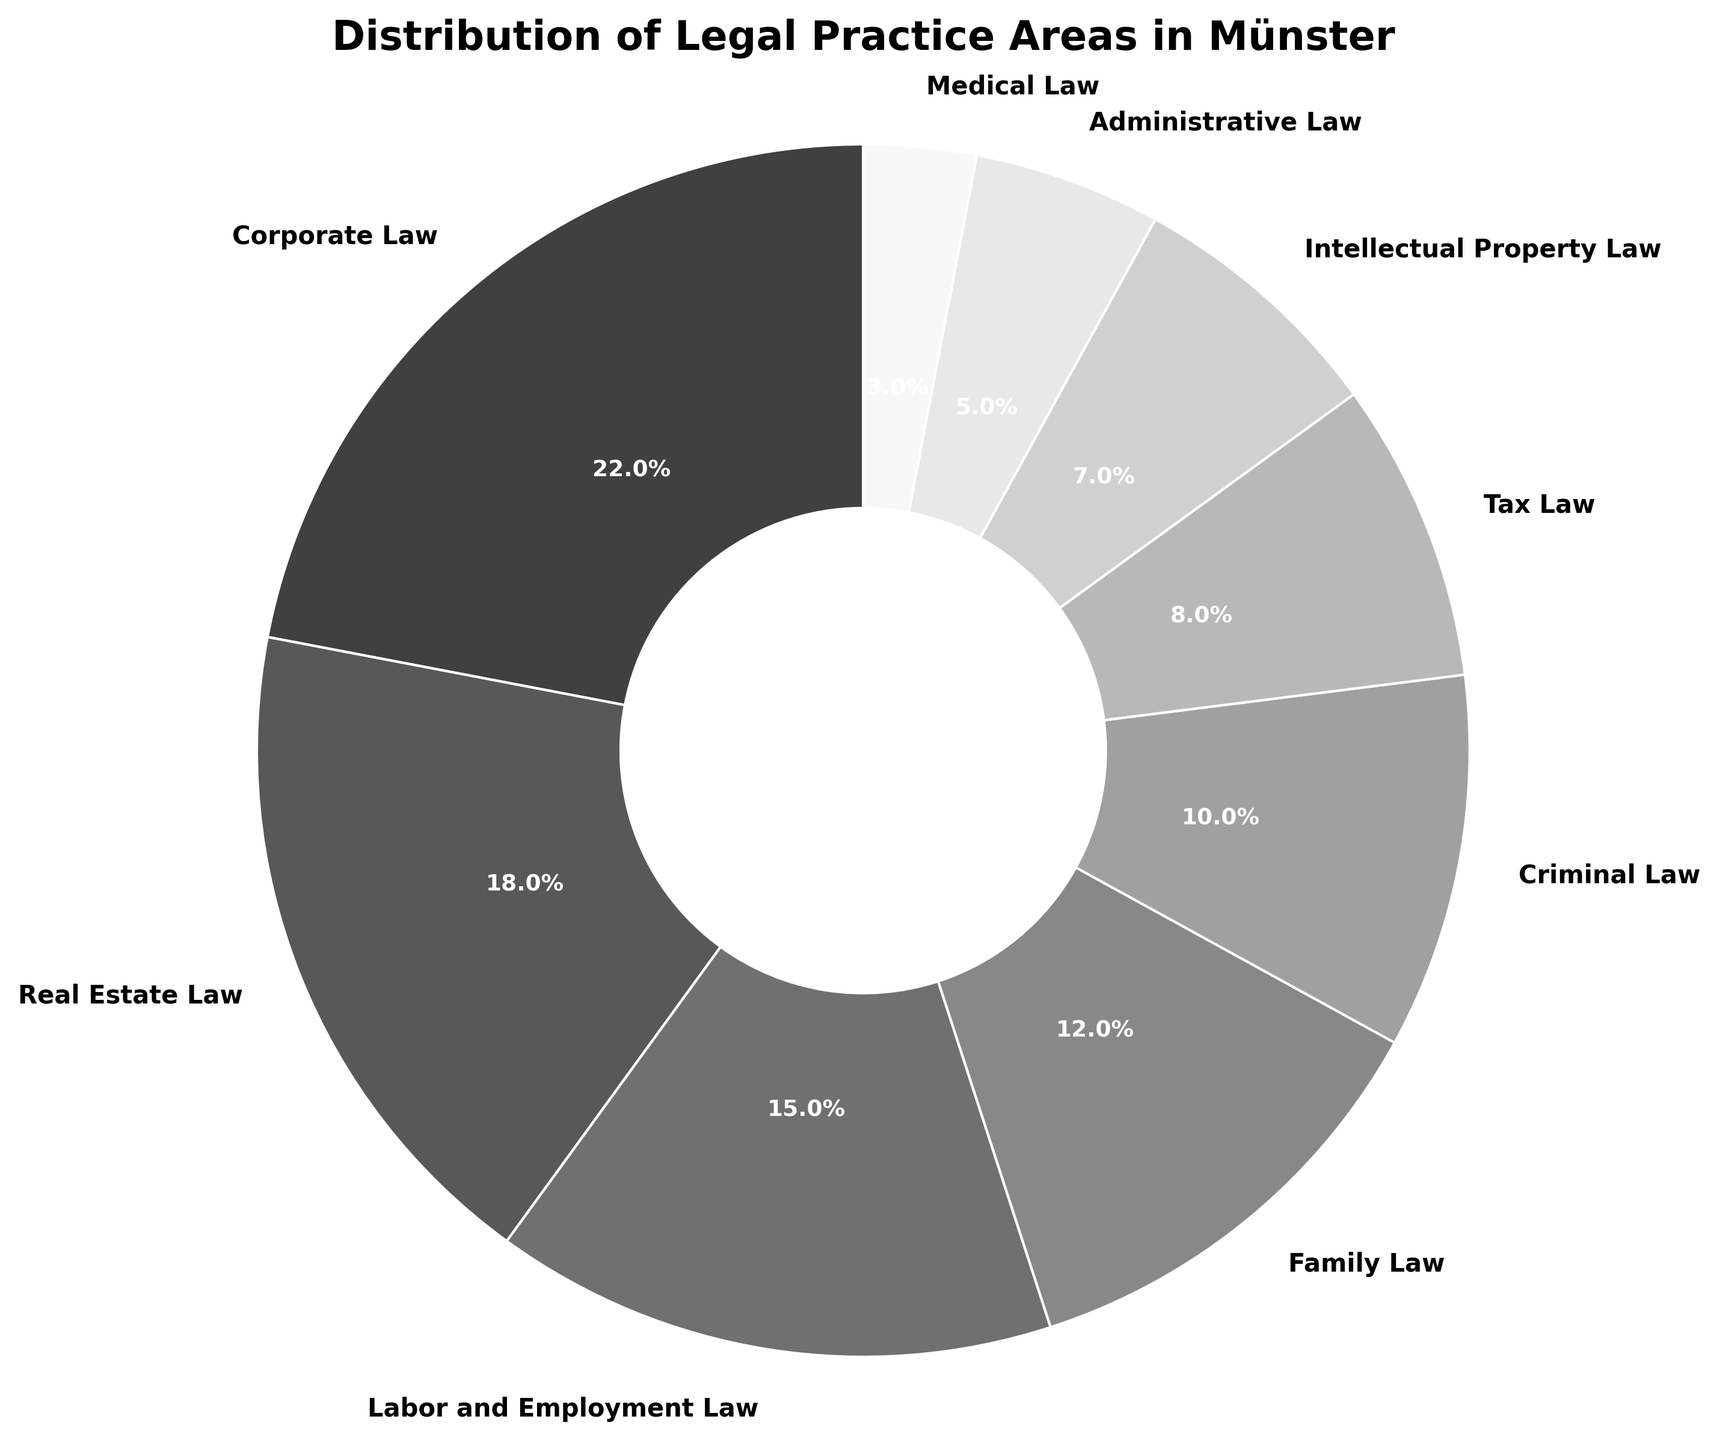what is the percentage difference between corporate law and real estate law? Corporate Law has 22% and Real Estate Law has 18%. The percentage difference is calculated as 22% - 18% = 4%.
Answer: 4% which legal practice area has the smallest percentage? The smallest slice in the chart represents Medical Law at 3%.
Answer: medical law how many legal practice areas have a percentage greater than or equal to 15%? Corporate Law (22%), Real Estate Law (18%) and Labor and Employment Law (15%) are above this threshold.
Answer: 3 identify three legal practice areas with percentages under 10%. The slices corresponding to Criminal Law (10%), Tax Law (8%), Intellectual Property Law (7%), Administrative Law (5%), and Medical Law (3%). The three areas under 10% are Tax Law, Intellectual Property Law, and Administrative Law.
Answer: Tax Law, Intellectual Property Law, Administrative Law what is the combined percentage of family law and criminal law? The combined percentage is the sum of Family Law (12%) and Criminal Law (10%), which equals 22%.
Answer: 22% which legal practice areas fall between the 5% and 17% range? Reviewing the chart, Labor and Employment Law (15%) and Family Law (12%) fall into this range.
Answer: Labor and Employment Law, Family Law what percentage does intellectual property law occupy relative to the smallest percentage represented? Intellectual Property Law has 7% and Medical Law has 3% (the smallest percentage). The relative percentage is 7% / 3% ≈ 2.33 times.
Answer: 2.33 times check the distribution: do corporate law and family law combined exceed real estate law and labor and employment law combined? The combined percentage for Corporate Law (22%) and Family Law (12%) is 34%. The combined percentage for Real Estate Law (18%) and Labor and Employment Law (15%) is 33%. Since 34% > 33%, yes, Corporate Law and Family Law together exceed the other two.
Answer: Yes which color corresponds to the legal practice area that represents 10% of the distribution? The area representing Criminal Law (10%) follows the grayscale theme, showing a shade that lies between #A0A0A0 and shades lighter than it.
Answer: light grey is there equal representation of any two legal practice areas? If so, which ones? No two areas seem to have identical percentages by examining the slices.
Answer: none 